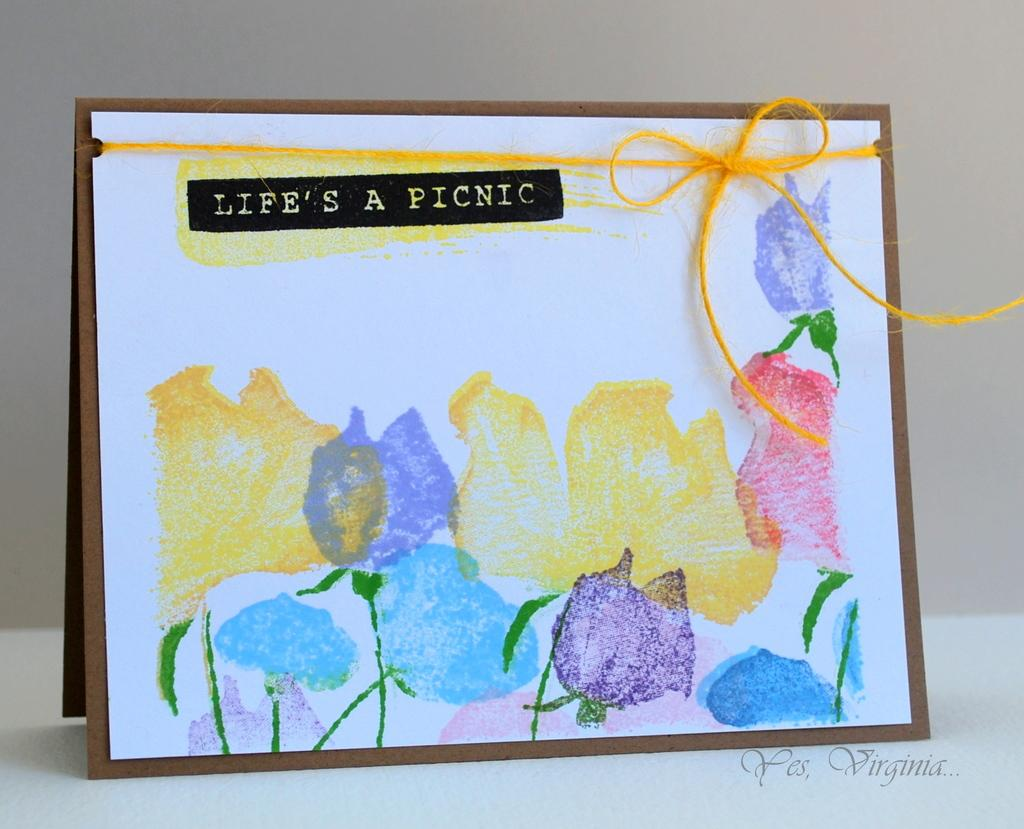What is depicted on the poster card in the image? There is a poster card with a sketch of flowers in the image. What additional information is provided about the sketch on the poster card? The poster card has text about the sketch. Where is the poster card located in the image? The poster card is on a table. What type of text can be seen at the bottom of the image? There is text at the bottom of the image. What type of ornament is hanging from the ceiling in the image? There is no ornament hanging from the ceiling in the image; the focus is on the poster card with a sketch of flowers. 